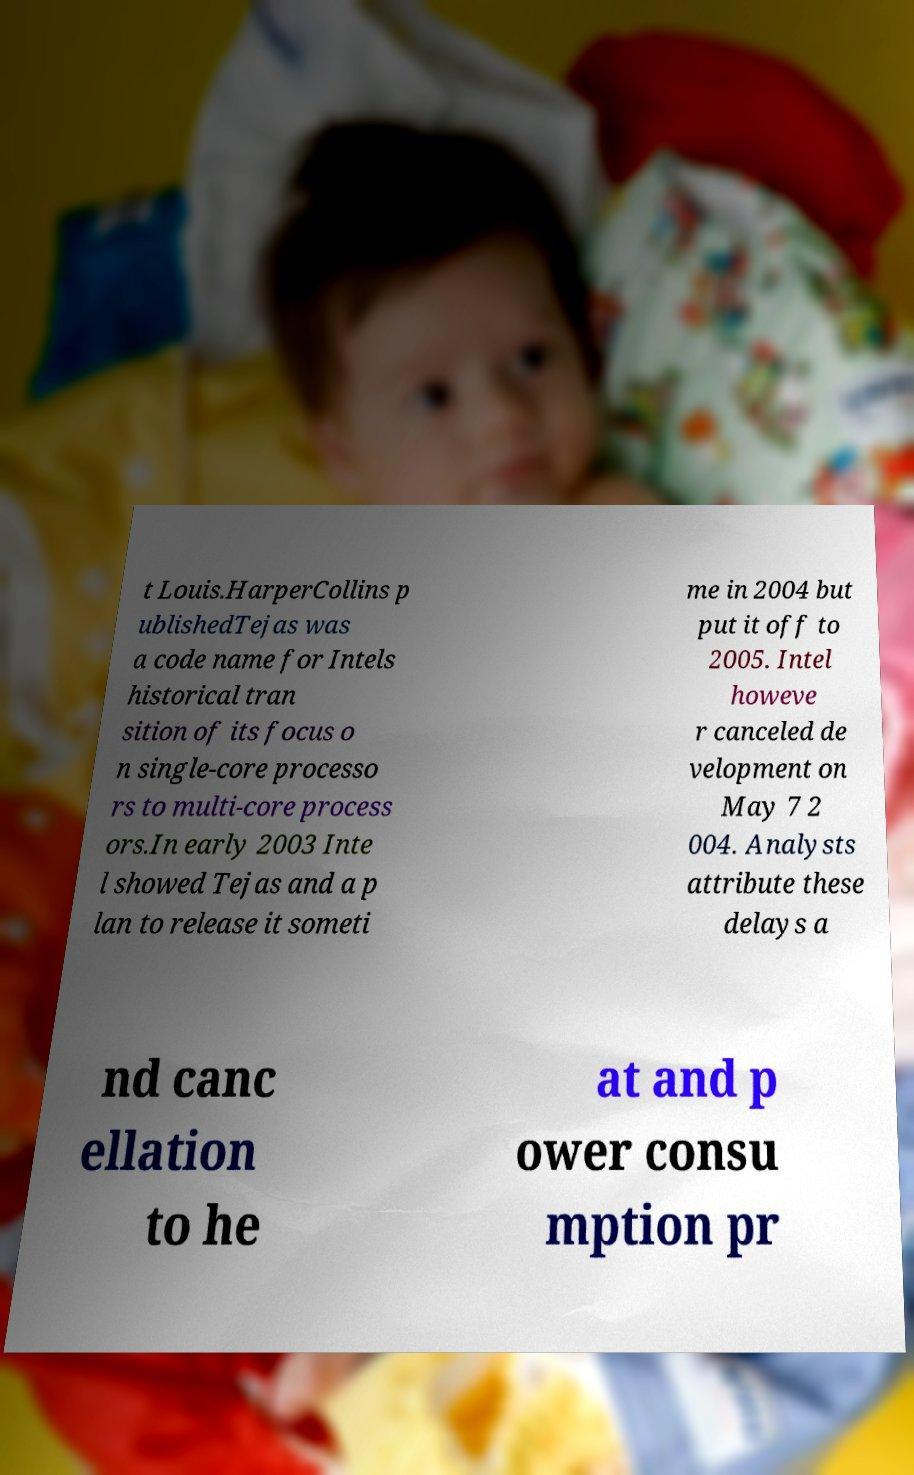I need the written content from this picture converted into text. Can you do that? t Louis.HarperCollins p ublishedTejas was a code name for Intels historical tran sition of its focus o n single-core processo rs to multi-core process ors.In early 2003 Inte l showed Tejas and a p lan to release it someti me in 2004 but put it off to 2005. Intel howeve r canceled de velopment on May 7 2 004. Analysts attribute these delays a nd canc ellation to he at and p ower consu mption pr 